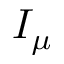Convert formula to latex. <formula><loc_0><loc_0><loc_500><loc_500>I _ { \mu }</formula> 